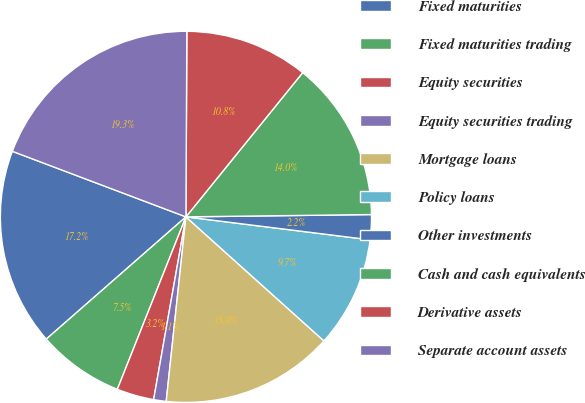<chart> <loc_0><loc_0><loc_500><loc_500><pie_chart><fcel>Fixed maturities<fcel>Fixed maturities trading<fcel>Equity securities<fcel>Equity securities trading<fcel>Mortgage loans<fcel>Policy loans<fcel>Other investments<fcel>Cash and cash equivalents<fcel>Derivative assets<fcel>Separate account assets<nl><fcel>17.19%<fcel>7.53%<fcel>3.24%<fcel>1.09%<fcel>15.04%<fcel>9.68%<fcel>2.17%<fcel>13.97%<fcel>10.75%<fcel>19.33%<nl></chart> 